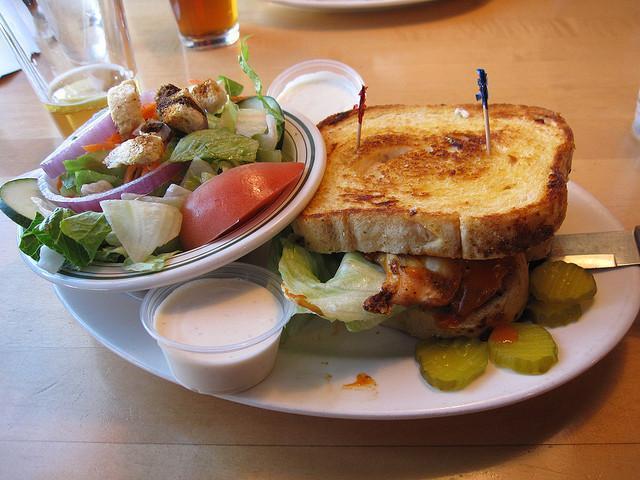Is the statement "The sandwich is in the bowl." accurate regarding the image?
Answer yes or no. No. 